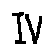<formula> <loc_0><loc_0><loc_500><loc_500>I V</formula> 